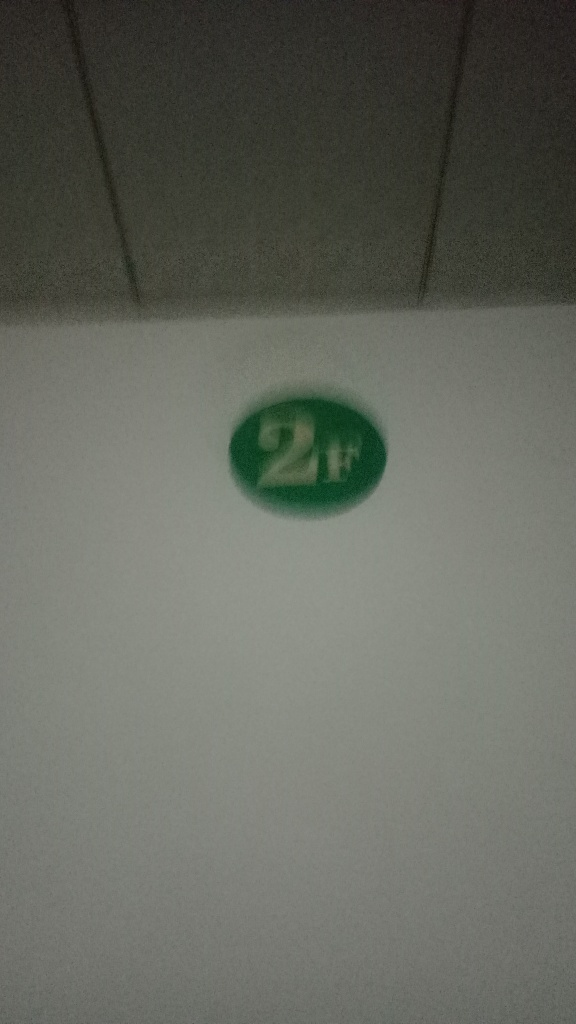Can you help me improve the quality of this image? To improve the quality of this image, you would need to retake the photo with better lighting, ensure the camera is focused properly, and stabilize the camera to avoid blurriness. If the green '2H' object is the subject, center it in the frame and try different angles to provide context. If the image is already captured and cannot be retaken, using photo editing software to adjust the brightness, contrast, and sharpness might help, but the initial quality may limit the extent of improvements possible. 